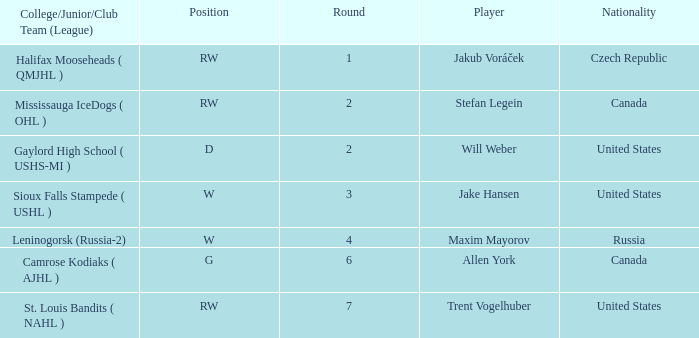Which country did the round 6 draft pick come from? Canada. 